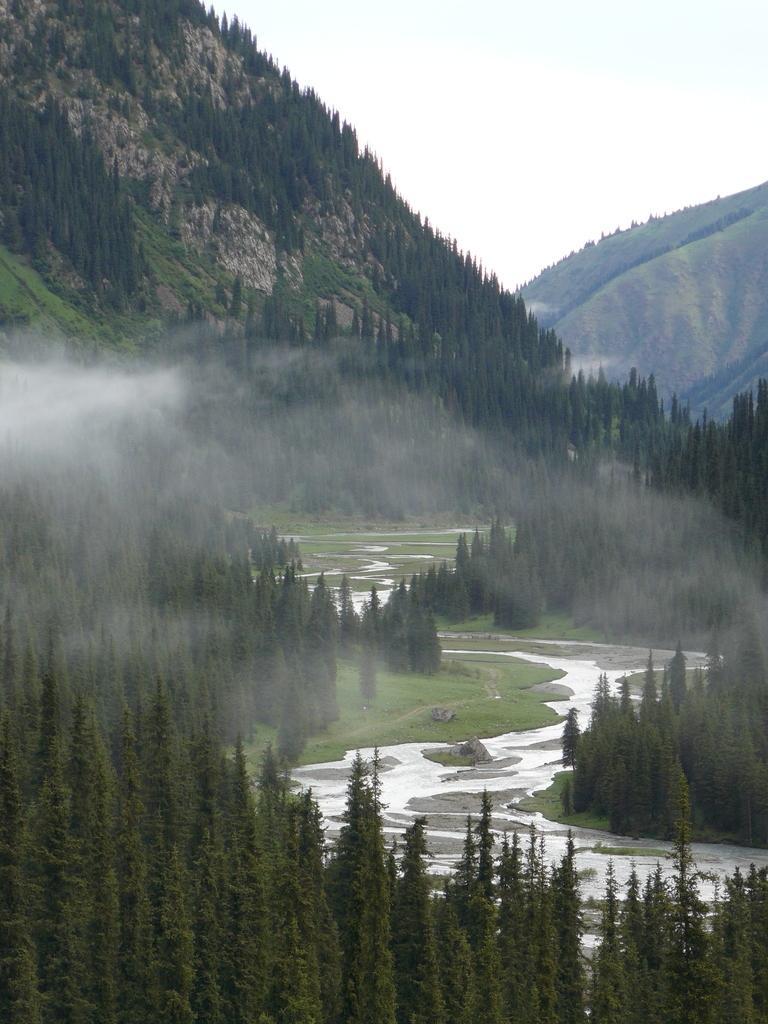Describe this image in one or two sentences. In the image we can see water, grass, trees, mountain and a sky. 